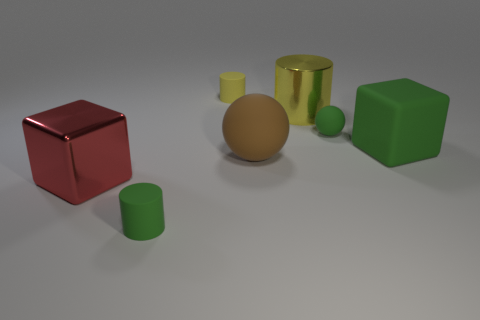There is a large cube to the right of the tiny green cylinder; does it have the same color as the tiny matte ball?
Provide a succinct answer. Yes. There is another matte thing that is the same shape as the yellow matte thing; what size is it?
Provide a short and direct response. Small. Is the material of the thing in front of the large red metallic object the same as the block that is to the right of the shiny cube?
Ensure brevity in your answer.  Yes. What number of metal objects are big cubes or tiny balls?
Your answer should be very brief. 1. The large thing that is on the left side of the tiny green rubber thing left of the large matte object that is left of the big green matte object is made of what material?
Your answer should be compact. Metal. There is a tiny green object behind the tiny green matte cylinder; is it the same shape as the small green thing on the left side of the green ball?
Offer a very short reply. No. What is the color of the large thing that is on the left side of the green matte object that is left of the small yellow rubber cylinder?
Offer a terse response. Red. What number of cylinders are small brown objects or green rubber objects?
Ensure brevity in your answer.  1. What number of brown matte balls are to the left of the tiny cylinder that is on the right side of the green matte object that is on the left side of the large yellow metallic cylinder?
Provide a short and direct response. 0. There is a rubber cube that is the same color as the tiny matte sphere; what size is it?
Offer a very short reply. Large. 